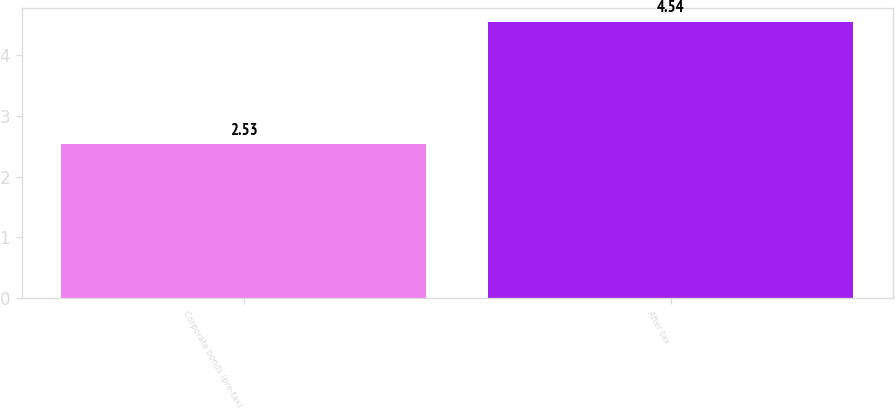<chart> <loc_0><loc_0><loc_500><loc_500><bar_chart><fcel>Corporate bonds (pre-tax)<fcel>After tax<nl><fcel>2.53<fcel>4.54<nl></chart> 